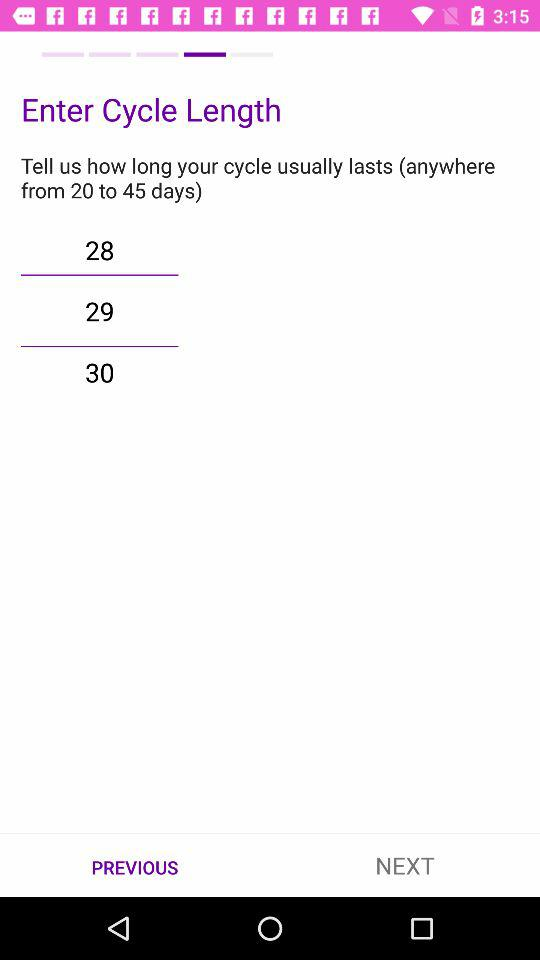What's the cycle length? The cycle length is 29. 